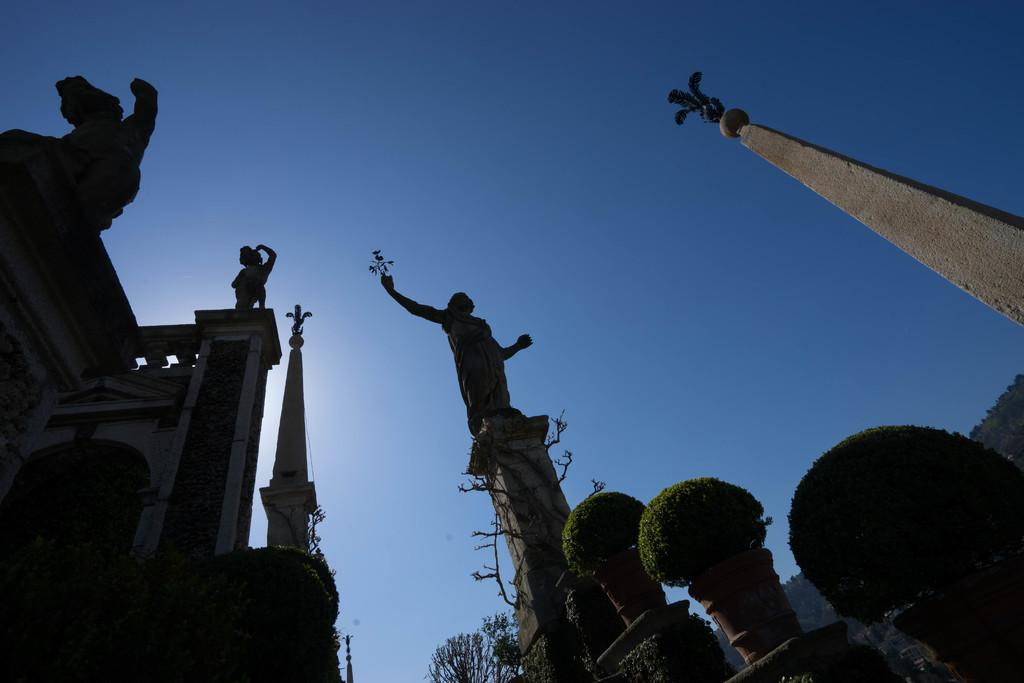What type of structures can be seen in the image? There are statues and pillars in the image. What type of vegetation is present in the image? There are plants in pots and a group of trees in the image. What is visible in the background of the image? The sky is visible in the image. How many clocks are hanging from the wrist of the statues in the image? There are no clocks or wrists visible in the image; it features statues, pillars, plants, trees, and the sky. 